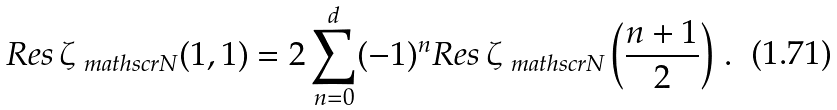<formula> <loc_0><loc_0><loc_500><loc_500>R e s \, \zeta _ { \ m a t h s c r { N } } ( 1 , 1 ) = 2 \sum _ { n = 0 } ^ { d } ( - 1 ) ^ { n } R e s \, \zeta _ { \ m a t h s c r { N } } \left ( \frac { n + 1 } { 2 } \right ) \, .</formula> 